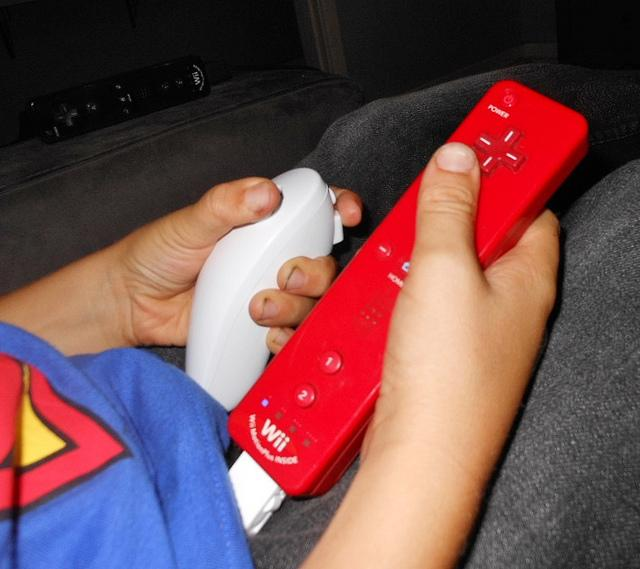What was the first item manufactured by the company that makes the remote? wii 